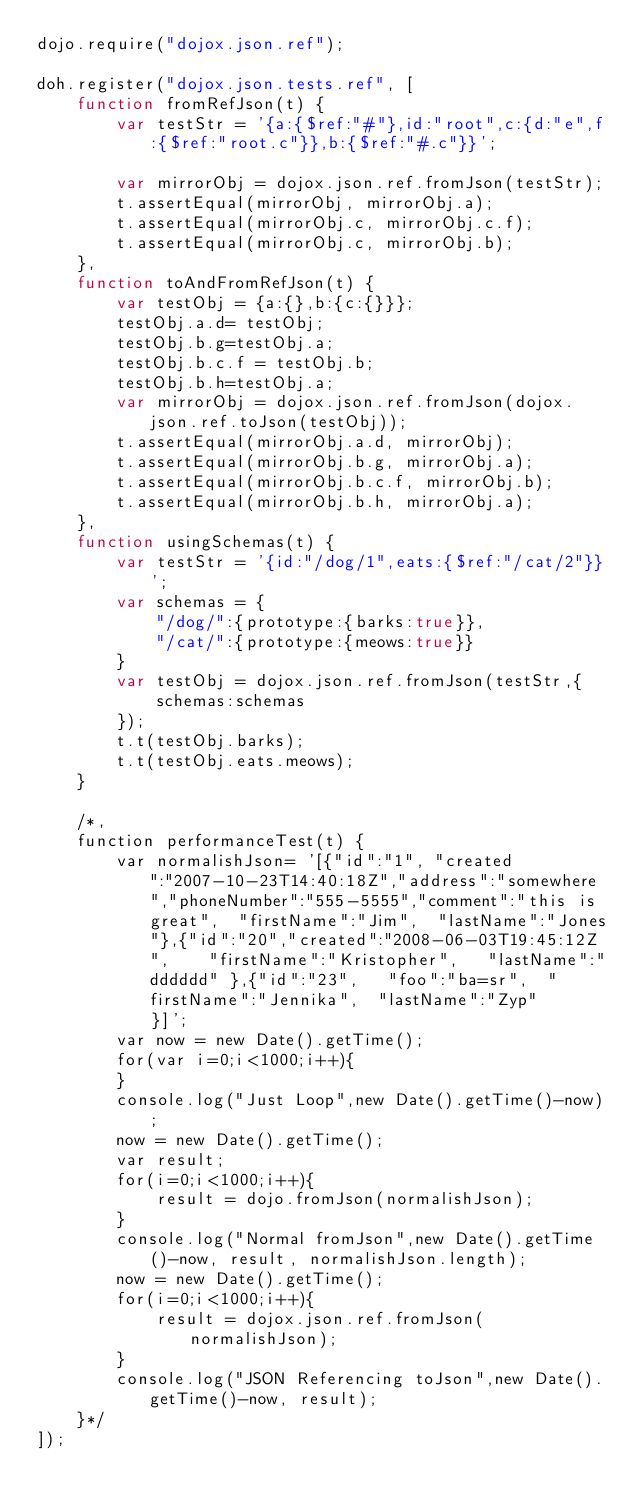Convert code to text. <code><loc_0><loc_0><loc_500><loc_500><_JavaScript_>dojo.require("dojox.json.ref");

doh.register("dojox.json.tests.ref", [
	function fromRefJson(t) {
		var testStr = '{a:{$ref:"#"},id:"root",c:{d:"e",f:{$ref:"root.c"}},b:{$ref:"#.c"}}';

		var mirrorObj = dojox.json.ref.fromJson(testStr);
		t.assertEqual(mirrorObj, mirrorObj.a);
		t.assertEqual(mirrorObj.c, mirrorObj.c.f);
		t.assertEqual(mirrorObj.c, mirrorObj.b);
	},
	function toAndFromRefJson(t) {
		var testObj = {a:{},b:{c:{}}};
		testObj.a.d= testObj;
		testObj.b.g=testObj.a;
		testObj.b.c.f = testObj.b;
		testObj.b.h=testObj.a;
		var mirrorObj = dojox.json.ref.fromJson(dojox.json.ref.toJson(testObj));
		t.assertEqual(mirrorObj.a.d, mirrorObj);
		t.assertEqual(mirrorObj.b.g, mirrorObj.a);
		t.assertEqual(mirrorObj.b.c.f, mirrorObj.b);
		t.assertEqual(mirrorObj.b.h, mirrorObj.a);
	},
	function usingSchemas(t) {
		var testStr = '{id:"/dog/1",eats:{$ref:"/cat/2"}}';
		var schemas = {
			"/dog/":{prototype:{barks:true}},
			"/cat/":{prototype:{meows:true}}
		}
		var testObj = dojox.json.ref.fromJson(testStr,{
			schemas:schemas
		});
		t.t(testObj.barks);
		t.t(testObj.eats.meows);
	}
	
	/*,
	function performanceTest(t) {
		var normalishJson= '[{"id":"1",	"created":"2007-10-23T14:40:18Z","address":"somewhere","phoneNumber":"555-5555","comment":"this is great",	"firstName":"Jim",	"lastName":"Jones"},{"id":"20","created":"2008-06-03T19:45:12Z",	"firstName":"Kristopher",	"lastName":"dddddd"	},{"id":"23",	"foo":"ba=sr",	"firstName":"Jennika",	"lastName":"Zyp"	}]';
		var now = new Date().getTime();
		for(var i=0;i<1000;i++){
		}
		console.log("Just Loop",new Date().getTime()-now);
		now = new Date().getTime();
		var result;
		for(i=0;i<1000;i++){
			result = dojo.fromJson(normalishJson);
		}
		console.log("Normal fromJson",new Date().getTime()-now, result, normalishJson.length);
		now = new Date().getTime();
		for(i=0;i<1000;i++){
			result = dojox.json.ref.fromJson(normalishJson);
		}
		console.log("JSON Referencing toJson",new Date().getTime()-now, result);
	}*/
]);
</code> 